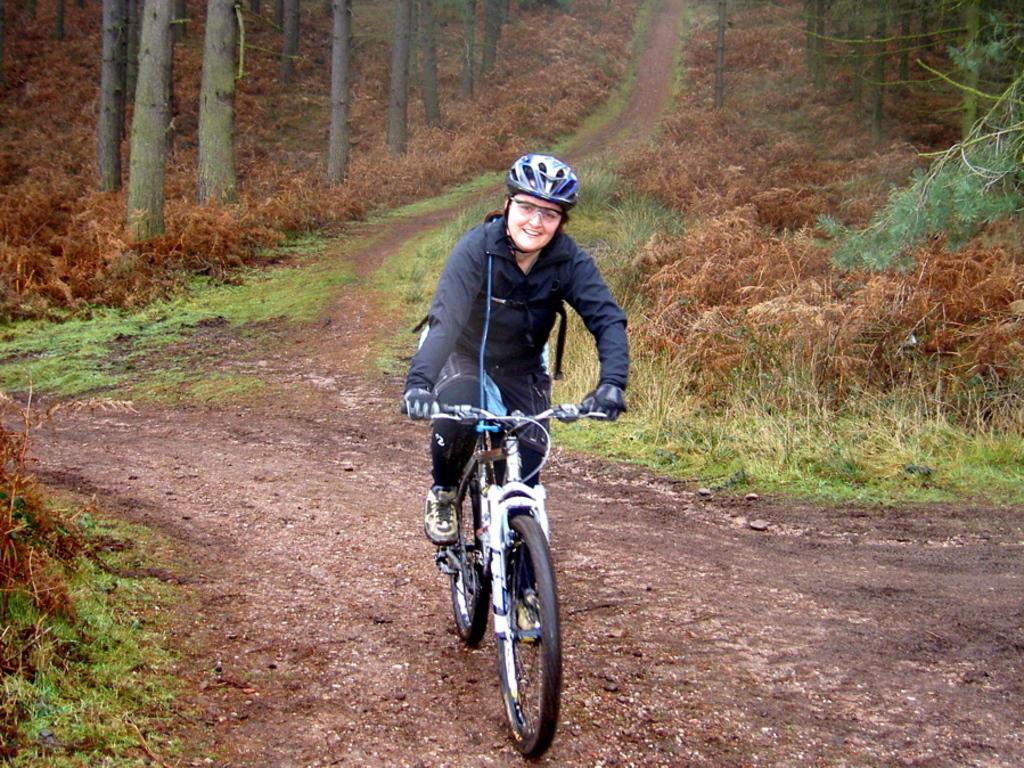Could you give a brief overview of what you see in this image? In the picture I can see a person wearing black color dress, glasses, helmet, shoes and gloves is riding the bicycle on the ground. Here I can see the grass, plants and trees in the background. 